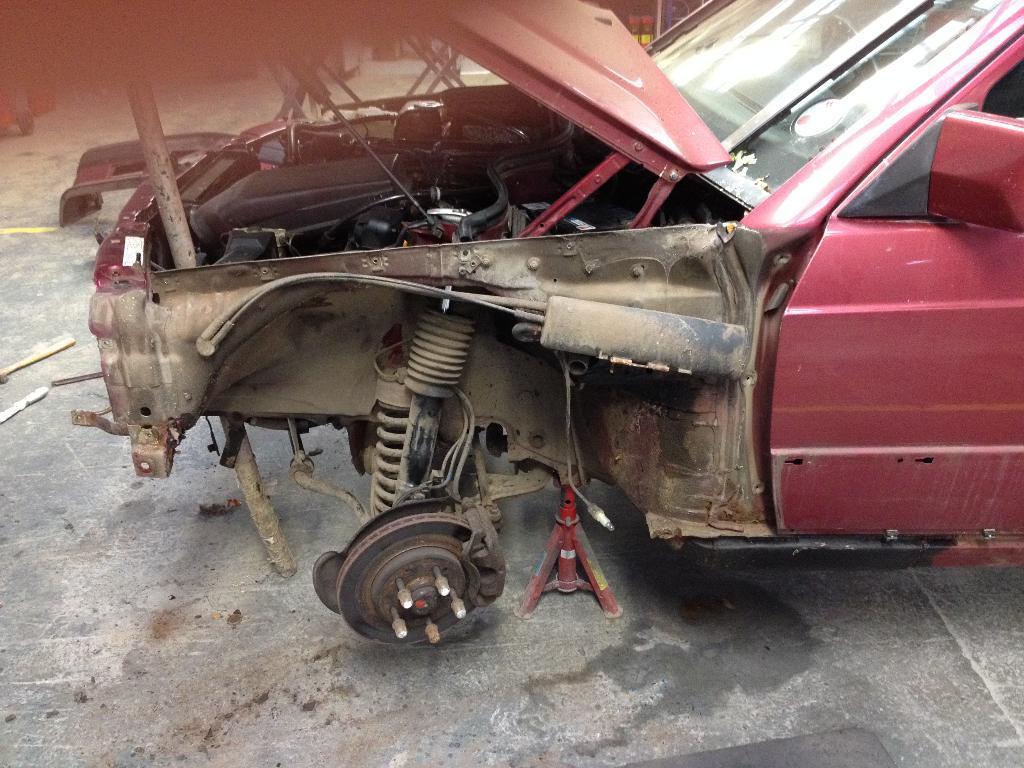In one or two sentences, can you explain what this image depicts? In the center of this picture we can see a red color vehicle. In the foreground we can see the ground. In the background there are some objects. 